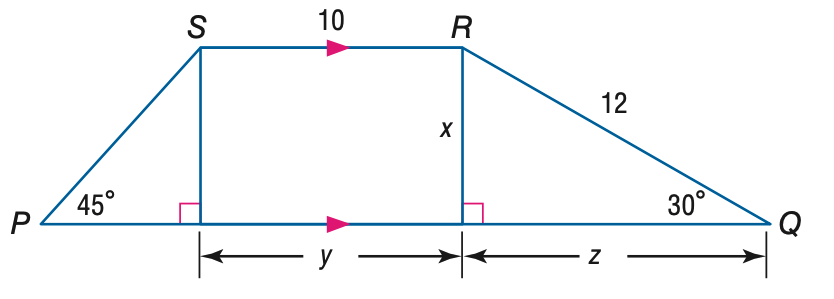Answer the mathemtical geometry problem and directly provide the correct option letter.
Question: Find x.
Choices: A: 6 B: 6 \sqrt { 2 } C: 6 \sqrt { 3 } D: 12 \sqrt { 3 } A 